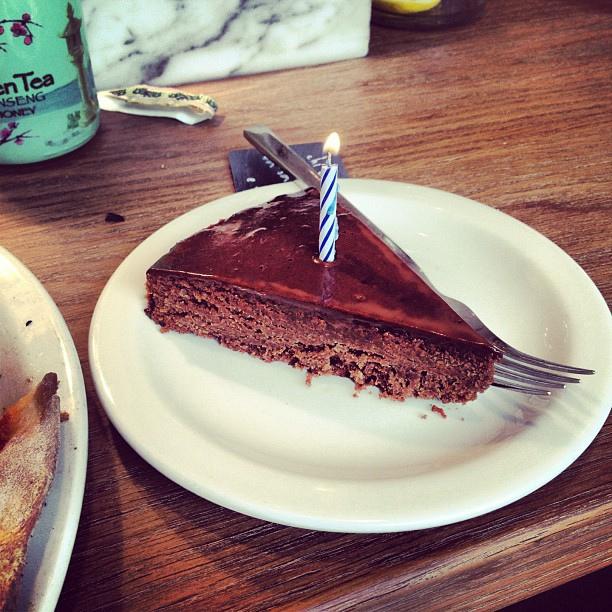Did someone take a bite of this?
Short answer required. No. Why would someone eat this?
Answer briefly. Birthday. Is it a birthday?
Quick response, please. Yes. What berry is on the pie?
Quick response, please. None. Is the cake angel food?
Quick response, please. No. What color stripes is the candle?
Answer briefly. Blue and white. 